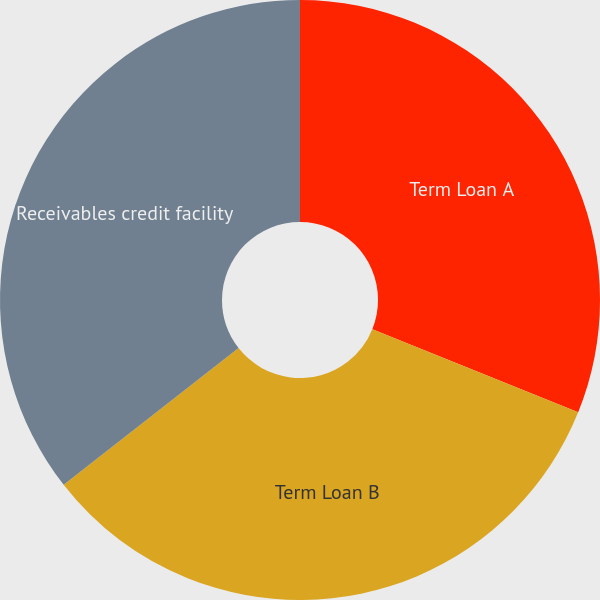Convert chart. <chart><loc_0><loc_0><loc_500><loc_500><pie_chart><fcel>Term Loan A<fcel>Term Loan B<fcel>Receivables credit facility<nl><fcel>31.11%<fcel>33.33%<fcel>35.56%<nl></chart> 